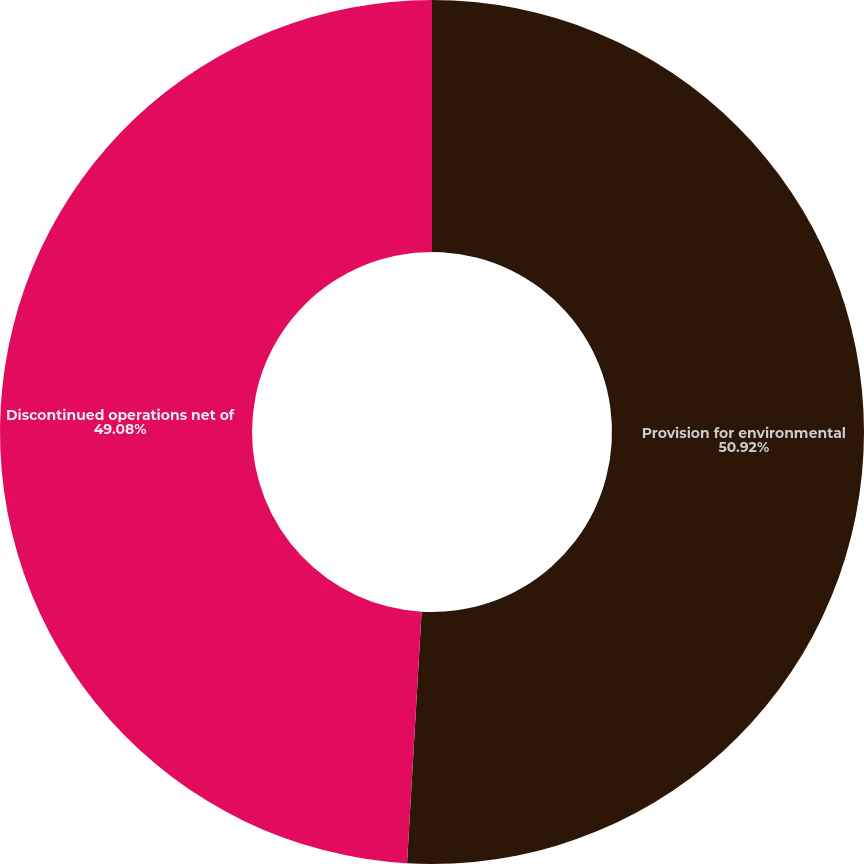<chart> <loc_0><loc_0><loc_500><loc_500><pie_chart><fcel>Provision for environmental<fcel>Discontinued operations net of<nl><fcel>50.92%<fcel>49.08%<nl></chart> 